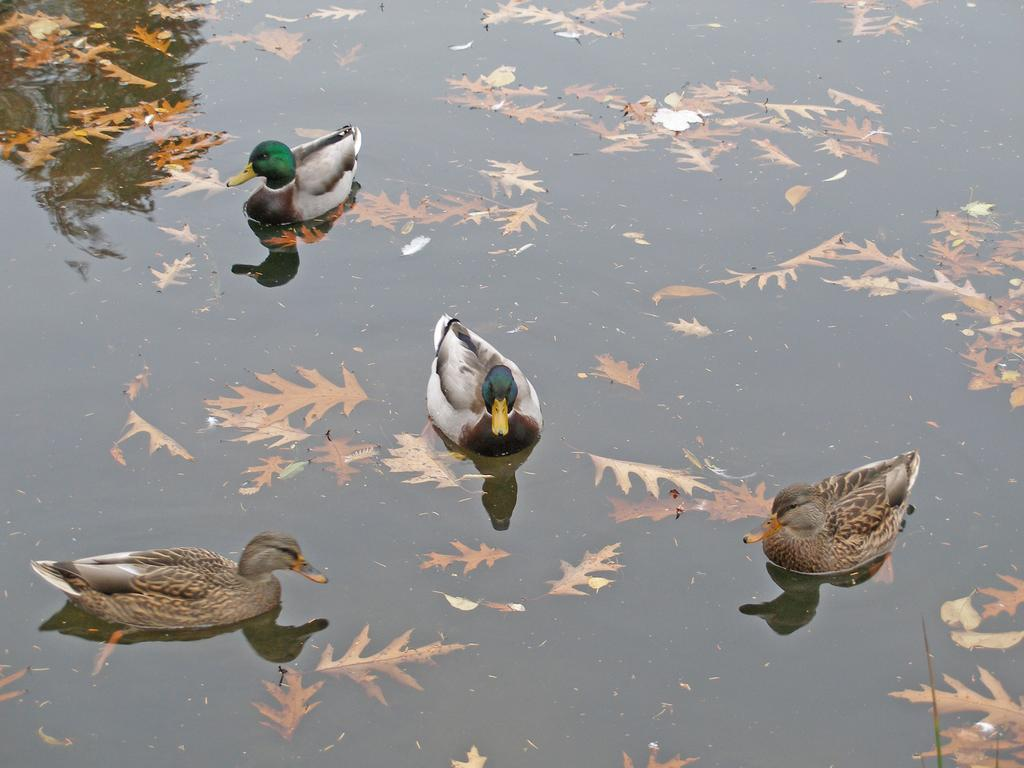What animals can be seen in the image? There are ducks in the image. What are the ducks doing in the image? The ducks are swimming in the water. What else can be seen in the water besides the ducks? There are leaves in the water. How many babies are present in the image? There are no babies present in the image; it features ducks swimming in the water. What type of design can be seen on the ducks' wings? There is no specific design mentioned on the ducks' wings in the image. 